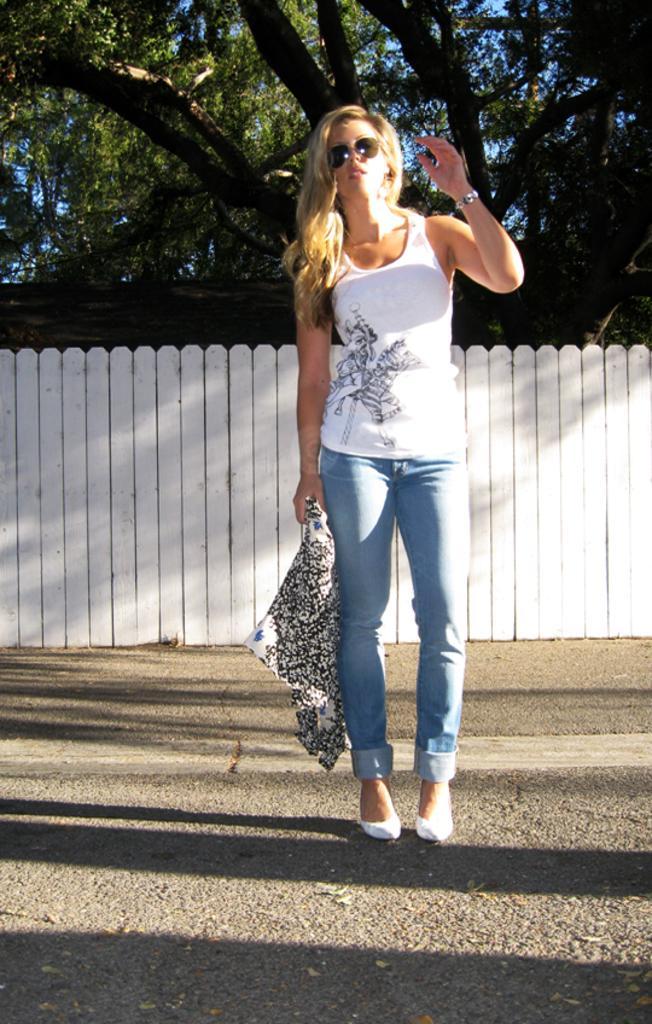Describe this image in one or two sentences. In the center of the picture there is a woman on the road. In the background there is railing, behind the railing there are trees. It is sunny. 